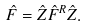Convert formula to latex. <formula><loc_0><loc_0><loc_500><loc_500>\hat { F } = \hat { Z } \hat { F } ^ { R } \hat { Z } .</formula> 